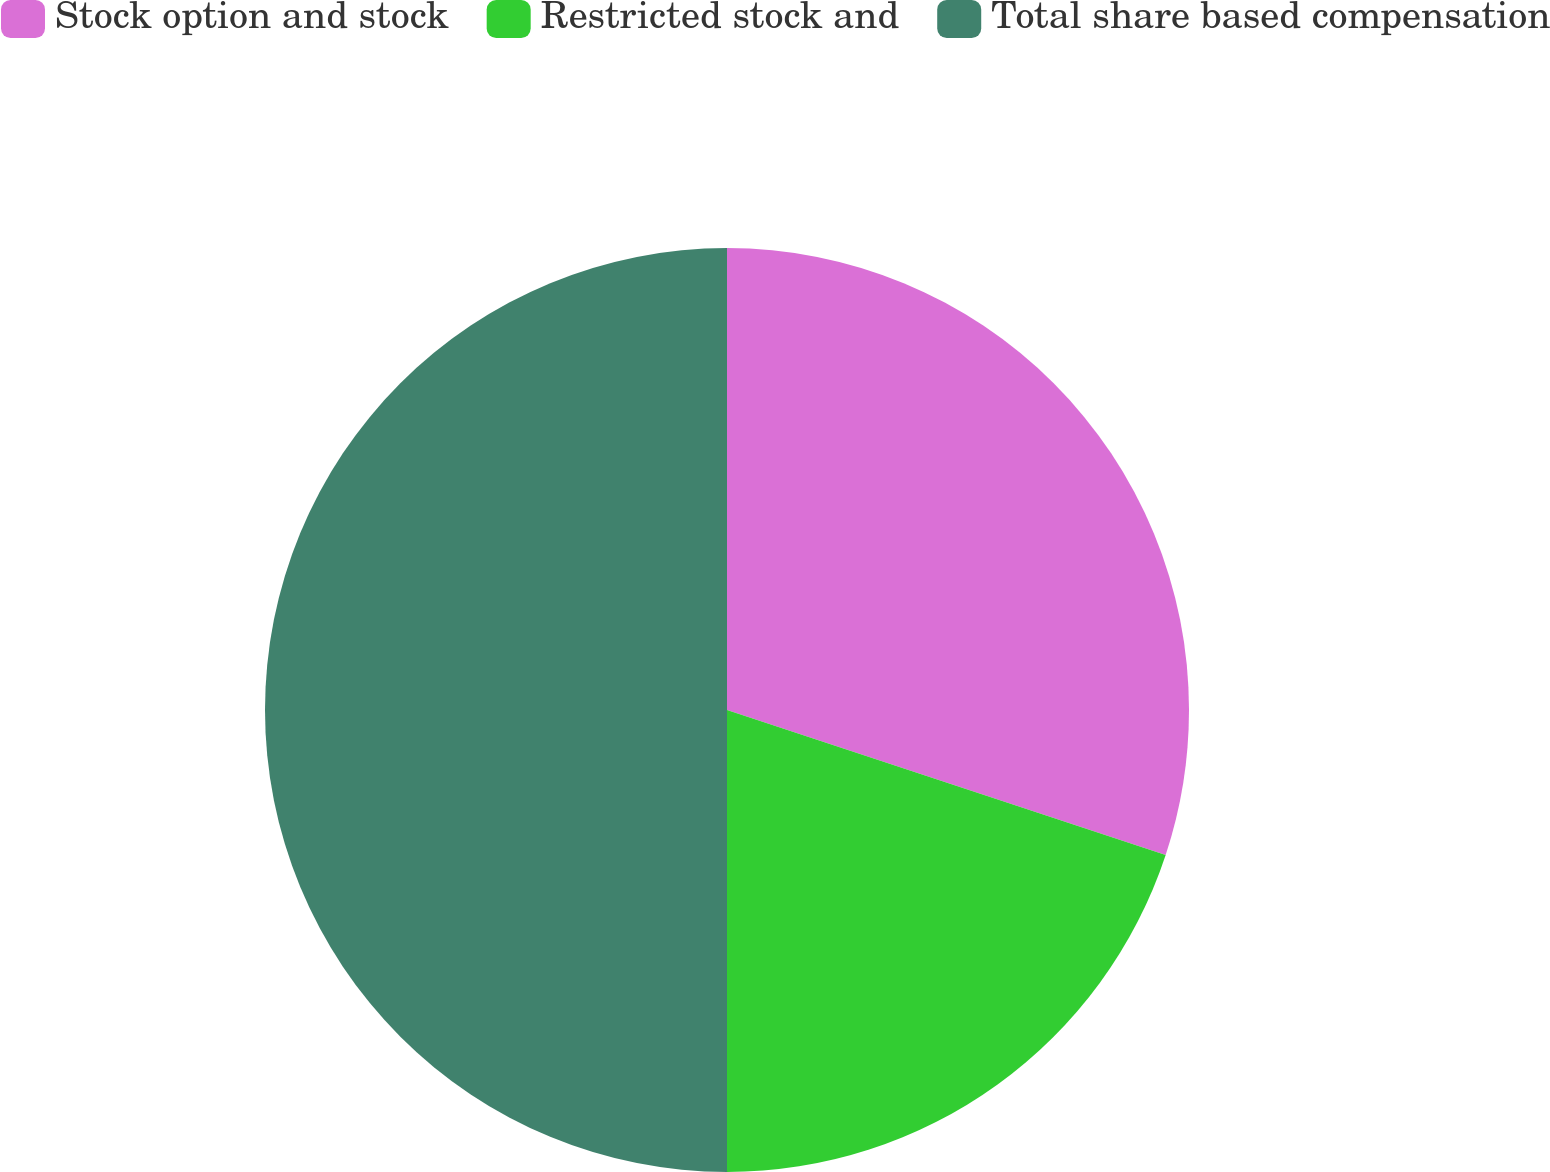Convert chart to OTSL. <chart><loc_0><loc_0><loc_500><loc_500><pie_chart><fcel>Stock option and stock<fcel>Restricted stock and<fcel>Total share based compensation<nl><fcel>30.08%<fcel>19.92%<fcel>50.0%<nl></chart> 